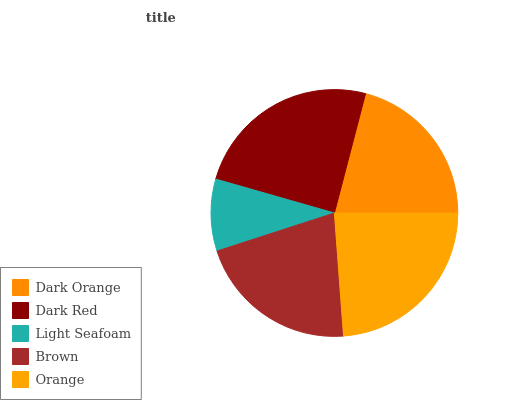Is Light Seafoam the minimum?
Answer yes or no. Yes. Is Dark Red the maximum?
Answer yes or no. Yes. Is Dark Red the minimum?
Answer yes or no. No. Is Light Seafoam the maximum?
Answer yes or no. No. Is Dark Red greater than Light Seafoam?
Answer yes or no. Yes. Is Light Seafoam less than Dark Red?
Answer yes or no. Yes. Is Light Seafoam greater than Dark Red?
Answer yes or no. No. Is Dark Red less than Light Seafoam?
Answer yes or no. No. Is Brown the high median?
Answer yes or no. Yes. Is Brown the low median?
Answer yes or no. Yes. Is Orange the high median?
Answer yes or no. No. Is Orange the low median?
Answer yes or no. No. 